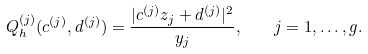Convert formula to latex. <formula><loc_0><loc_0><loc_500><loc_500>Q _ { h } ^ { ( j ) } ( c ^ { ( j ) } , d ^ { ( j ) } ) = \frac { | c ^ { ( j ) } z _ { j } + d ^ { ( j ) } | ^ { 2 } } { y _ { j } } , \quad j = 1 , \dots , g .</formula> 